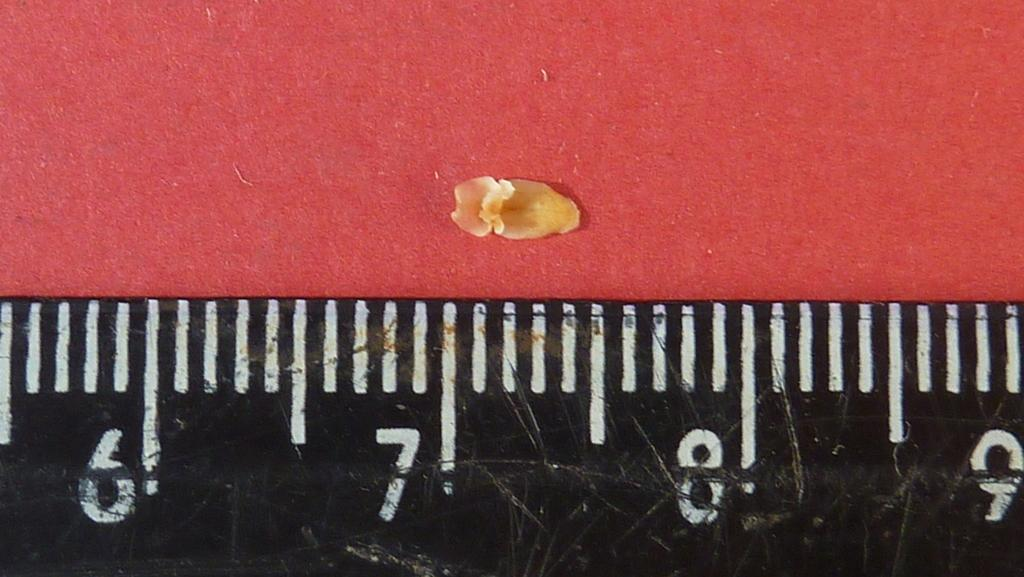<image>
Write a terse but informative summary of the picture. Black ruler that goes up to 9 measuring a tiny object. 